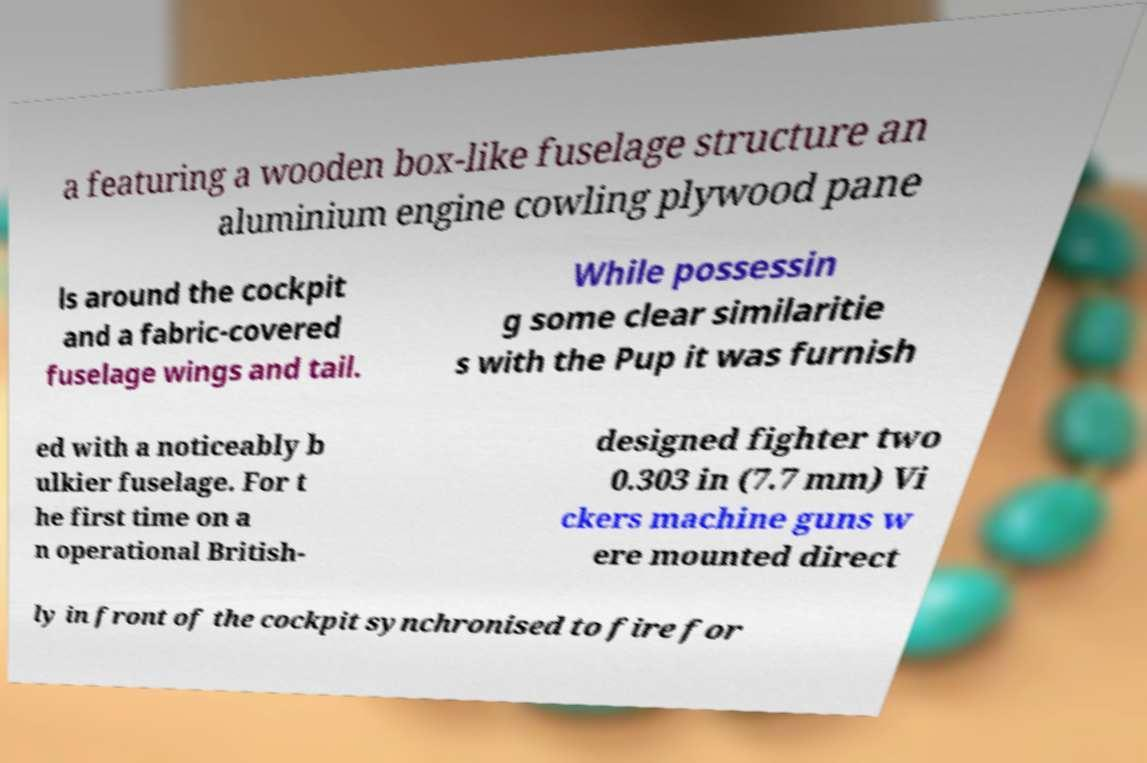Please identify and transcribe the text found in this image. a featuring a wooden box-like fuselage structure an aluminium engine cowling plywood pane ls around the cockpit and a fabric-covered fuselage wings and tail. While possessin g some clear similaritie s with the Pup it was furnish ed with a noticeably b ulkier fuselage. For t he first time on a n operational British- designed fighter two 0.303 in (7.7 mm) Vi ckers machine guns w ere mounted direct ly in front of the cockpit synchronised to fire for 